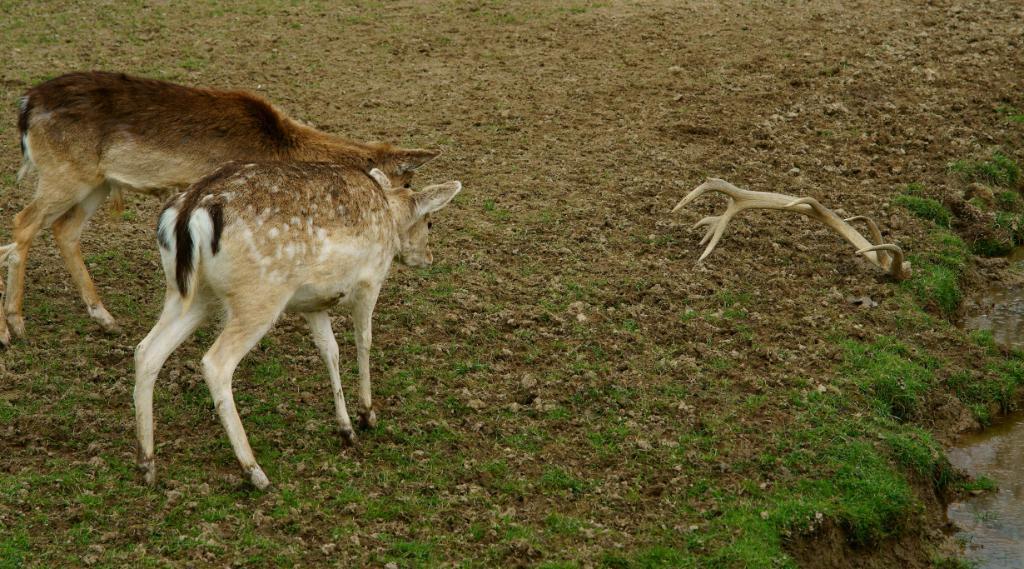Please provide a concise description of this image. This image consists of deer. At the bottom, there is green grass on the ground. On the right, we can see water. And we can see the horns of a deer. 